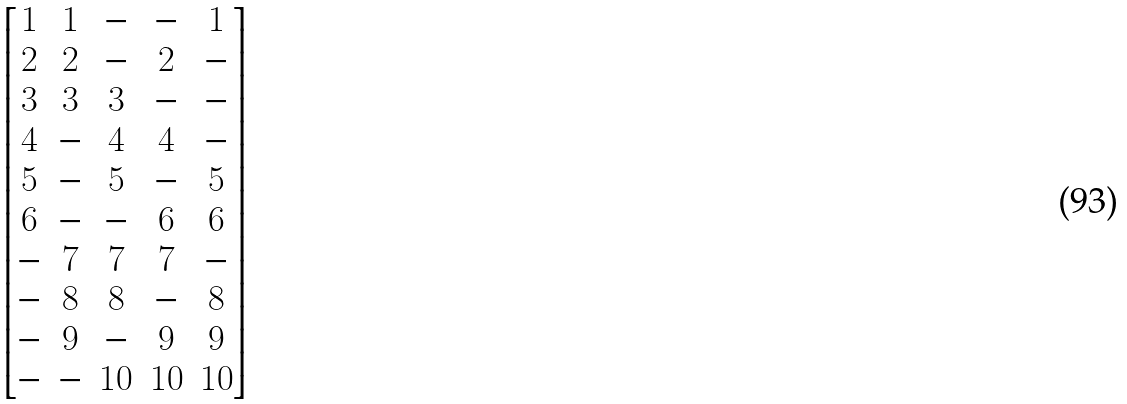Convert formula to latex. <formula><loc_0><loc_0><loc_500><loc_500>\begin{bmatrix} 1 & 1 & - & - & 1 \\ 2 & 2 & - & 2 & - \\ 3 & 3 & 3 & - & - \\ 4 & - & 4 & 4 & - \\ 5 & - & 5 & - & 5 \\ 6 & - & - & 6 & 6 \\ - & 7 & 7 & 7 & - \\ - & 8 & 8 & - & 8 \\ - & 9 & - & 9 & 9 \\ - & - & 1 0 & 1 0 & 1 0 \\ \end{bmatrix}</formula> 